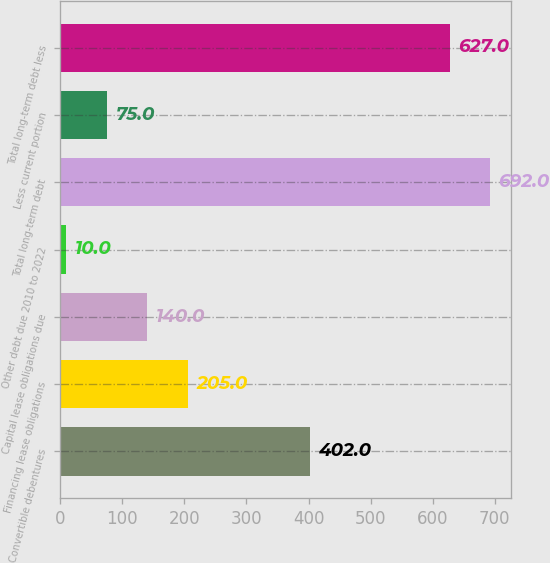<chart> <loc_0><loc_0><loc_500><loc_500><bar_chart><fcel>Convertible debentures<fcel>Financing lease obligations<fcel>Capital lease obligations due<fcel>Other debt due 2010 to 2022<fcel>Total long-term debt<fcel>Less current portion<fcel>Total long-term debt less<nl><fcel>402<fcel>205<fcel>140<fcel>10<fcel>692<fcel>75<fcel>627<nl></chart> 